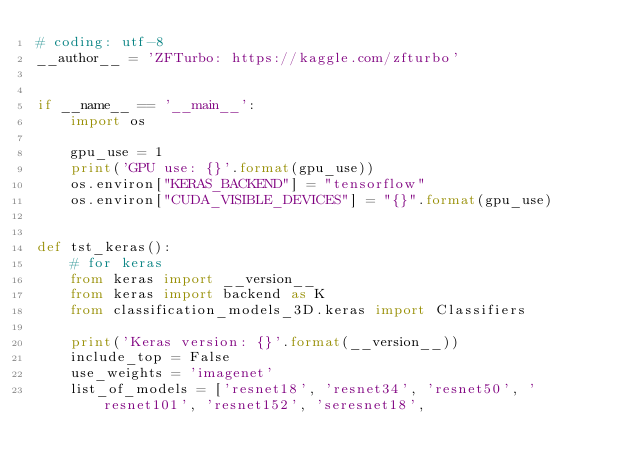Convert code to text. <code><loc_0><loc_0><loc_500><loc_500><_Python_># coding: utf-8
__author__ = 'ZFTurbo: https://kaggle.com/zfturbo'


if __name__ == '__main__':
    import os

    gpu_use = 1
    print('GPU use: {}'.format(gpu_use))
    os.environ["KERAS_BACKEND"] = "tensorflow"
    os.environ["CUDA_VISIBLE_DEVICES"] = "{}".format(gpu_use)


def tst_keras():
    # for keras
    from keras import __version__
    from keras import backend as K
    from classification_models_3D.keras import Classifiers

    print('Keras version: {}'.format(__version__))
    include_top = False
    use_weights = 'imagenet'
    list_of_models = ['resnet18', 'resnet34', 'resnet50', 'resnet101', 'resnet152', 'seresnet18',</code> 